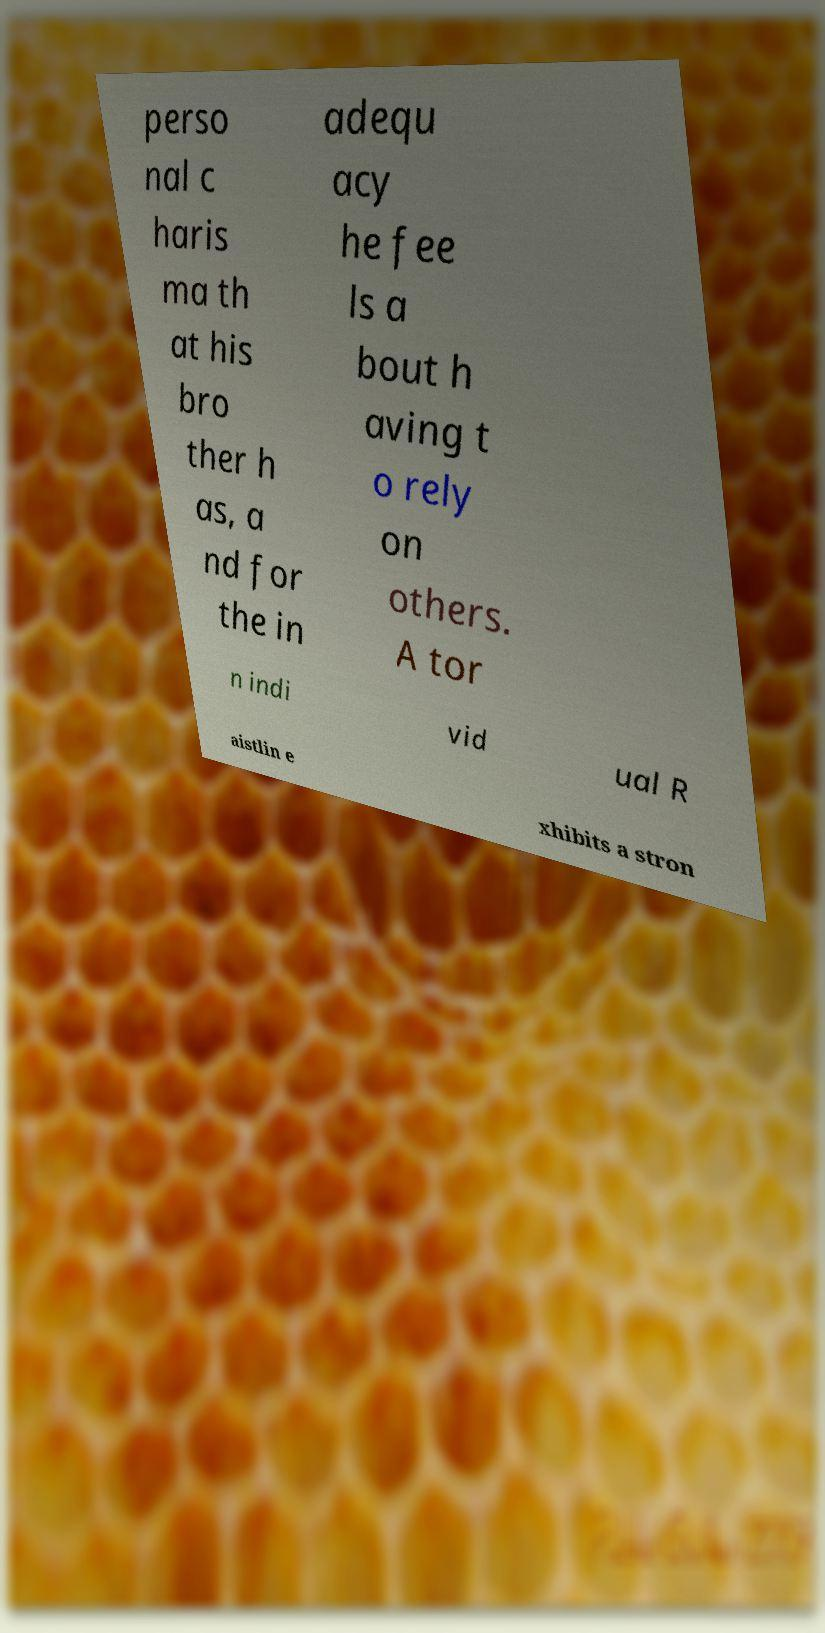Can you accurately transcribe the text from the provided image for me? perso nal c haris ma th at his bro ther h as, a nd for the in adequ acy he fee ls a bout h aving t o rely on others. A tor n indi vid ual R aistlin e xhibits a stron 